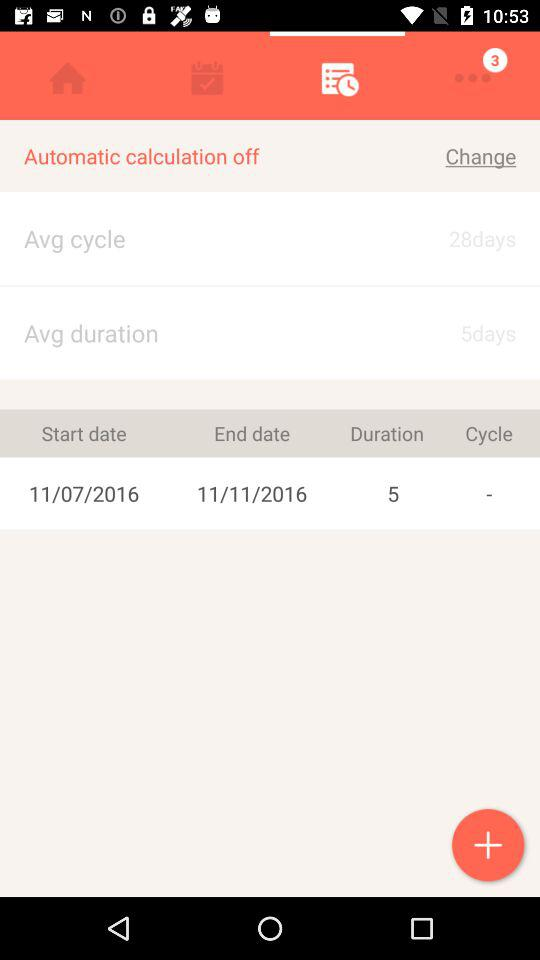What is the average duration? The average duration is "5days". 